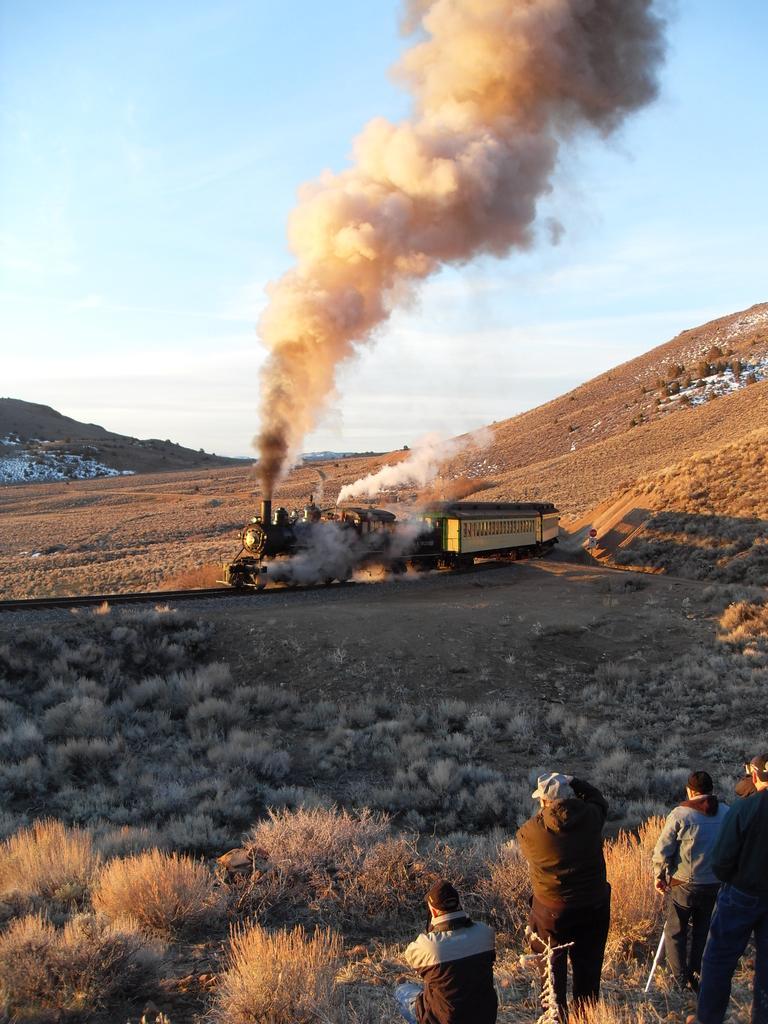How would you summarize this image in a sentence or two? In this image we can see a few people and there is a train on the railway track and we can see grass on the ground. We can see the mountains in the background and at the top we can see the sky. 